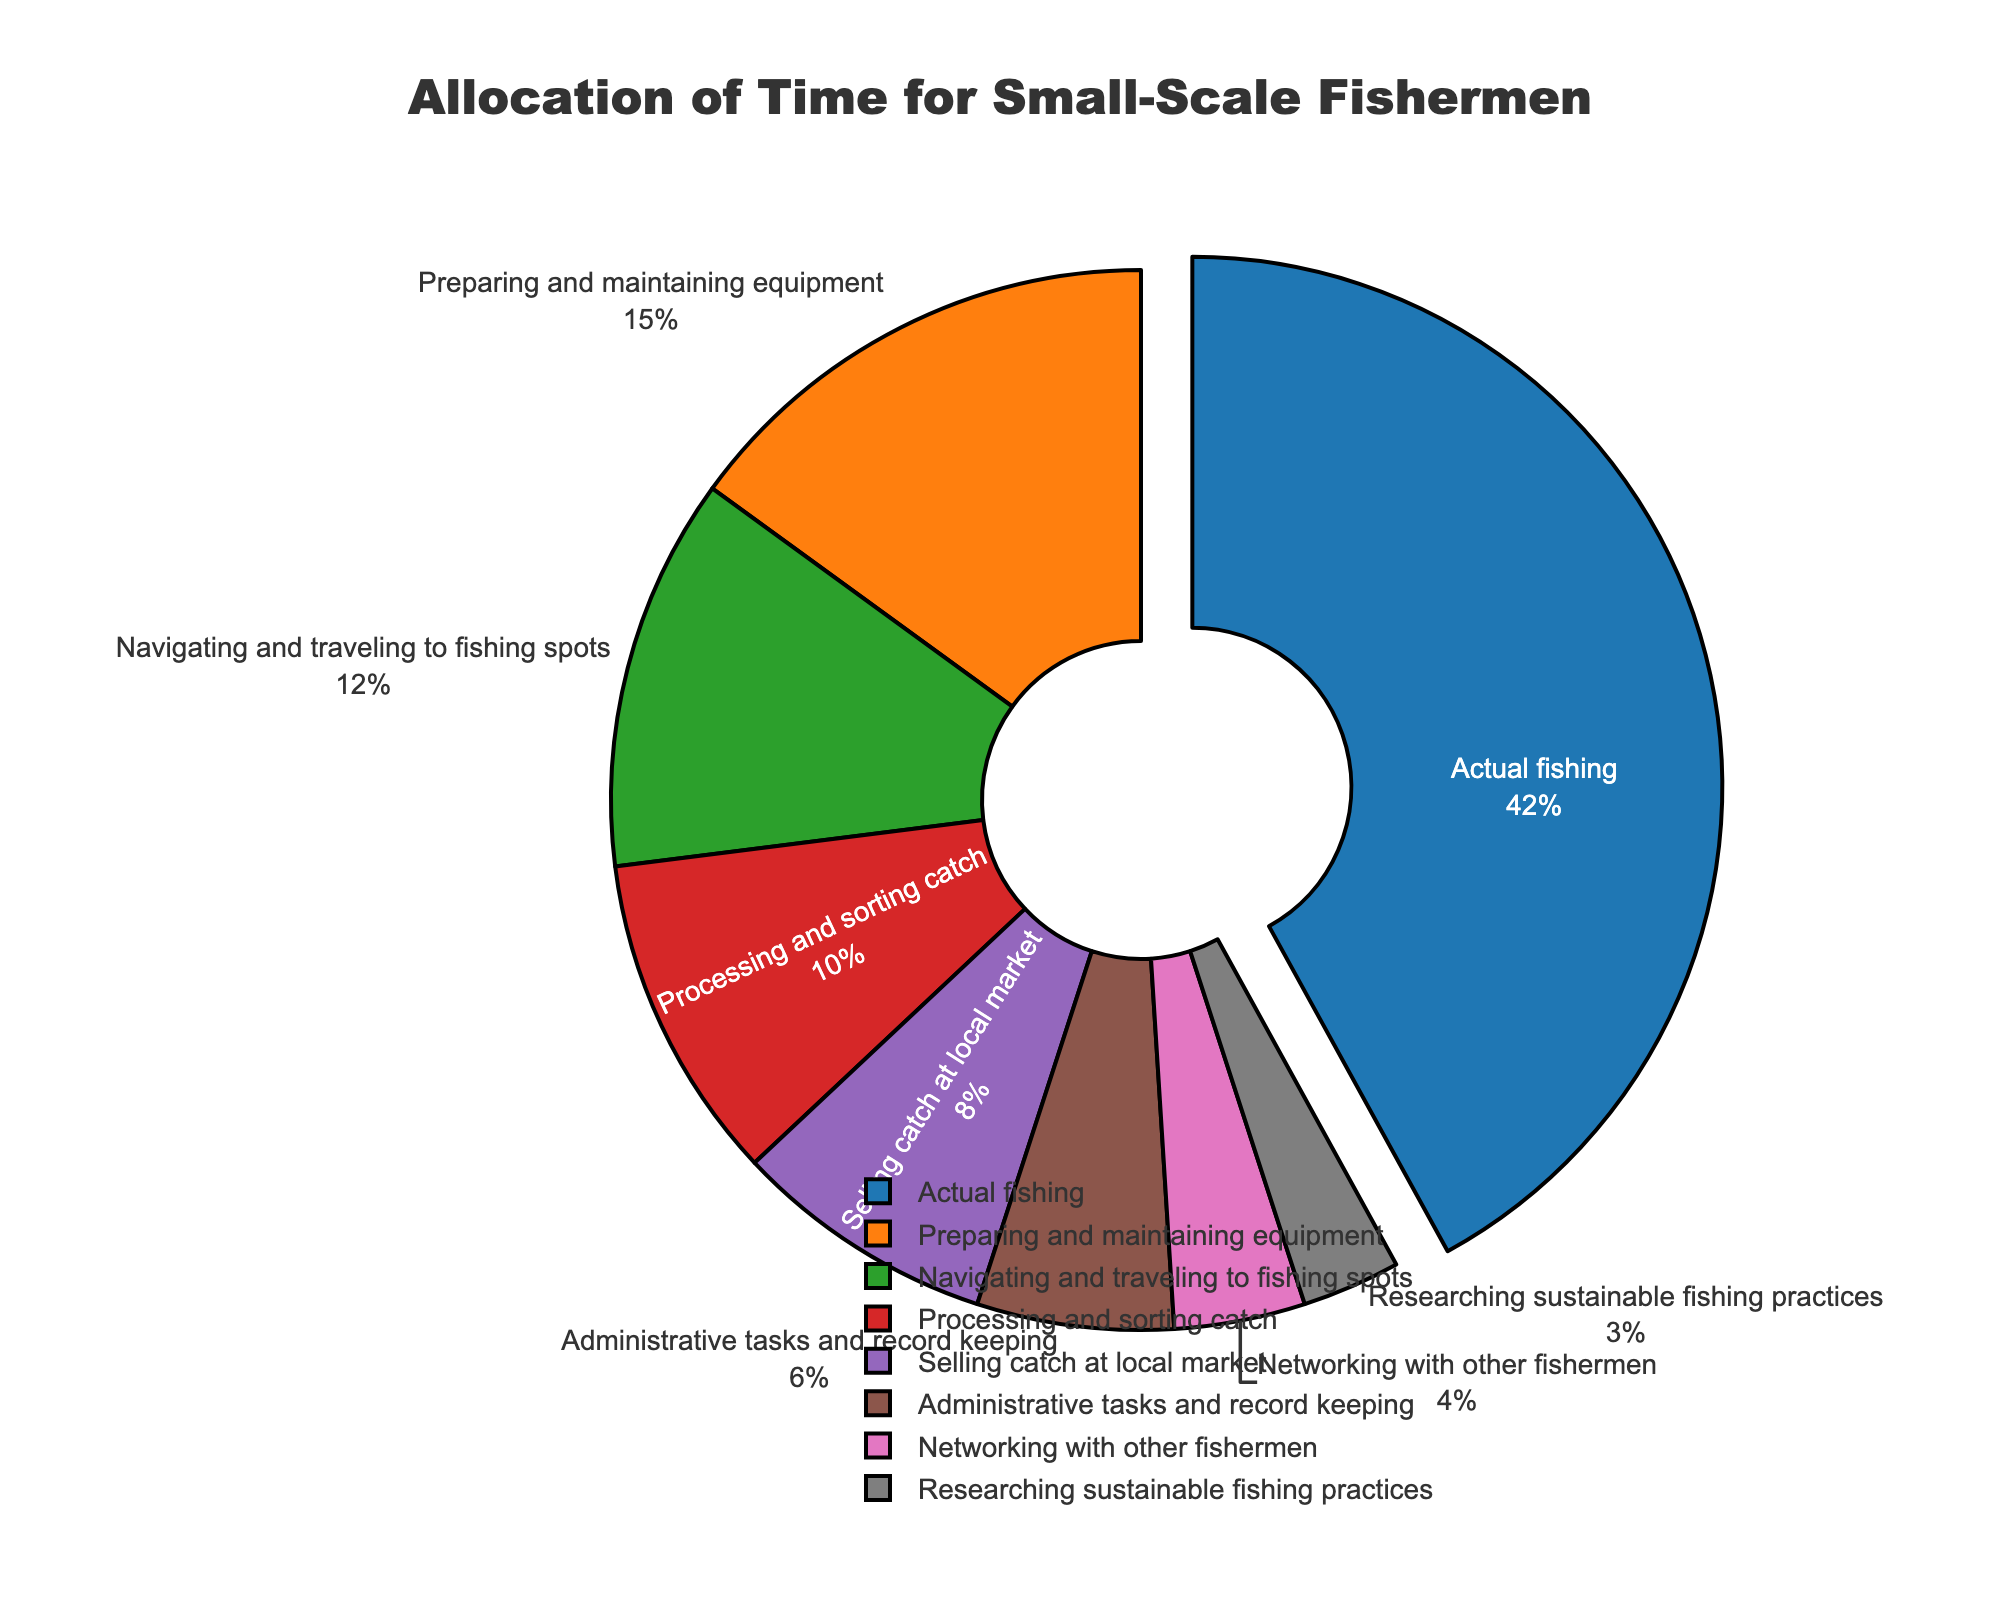Which activity takes up the largest proportion of time? The slice for "Actual fishing" is visually the largest and is slightly pulled out for emphasis, representing the highest percentage of time spent.
Answer: Actual fishing How many hours in total are spent on activities other than actual fishing and preparing/maintaining equipment? Adding the hours for all activities excluding "Actual fishing" (42 hours) and "Preparing and maintaining equipment" (15 hours): 12 (Navigating and traveling) + 10 (Processing and sorting catch) + 8 (Selling catch) + 6 (Administrative tasks) + 4 (Networking) + 3 (Research) = 43 hours.
Answer: 43 hours Which two activities combined equal the time spent on preparing and maintaining equipment? The sum of hours for "Researching sustainable fishing practices" (3 hours) and "Networking with other fishermen" (4 hours) is 3 + 4 = 7 hours. Adding this to "Administrative tasks and record keeping" (6 hours) gives 7 + 6 = 13 hours, which is close to the total for "Preparing and maintaining equipment" (15 hours). However, combining "Processing and sorting catch" (10 hours) and "Selling catch at local market" (8 hours) accurately gives 10 + 8 = 18 hours.
Answer: Processing and sorting catch & Selling catch at local market What proportion of time is spent on administrative tasks and networking combined? The combined hours for "Administrative tasks and record keeping" (6 hours) and "Networking with other fishermen" (4 hours) is 6 + 4 = 10 hours. Divide this by the total hours (100) to get the proportion: 10/100 = 10%.
Answer: 10% How does the time spent on navigating and traveling compare to selling at local markets? From the pie chart, "Navigating and traveling to fishing spots" is allocated 12 hours, while "Selling catch at local market" is allocated 8 hours. The chart visually shows that navigating and traveling takes up a larger proportion of time.
Answer: More time is spent on navigating and traveling 